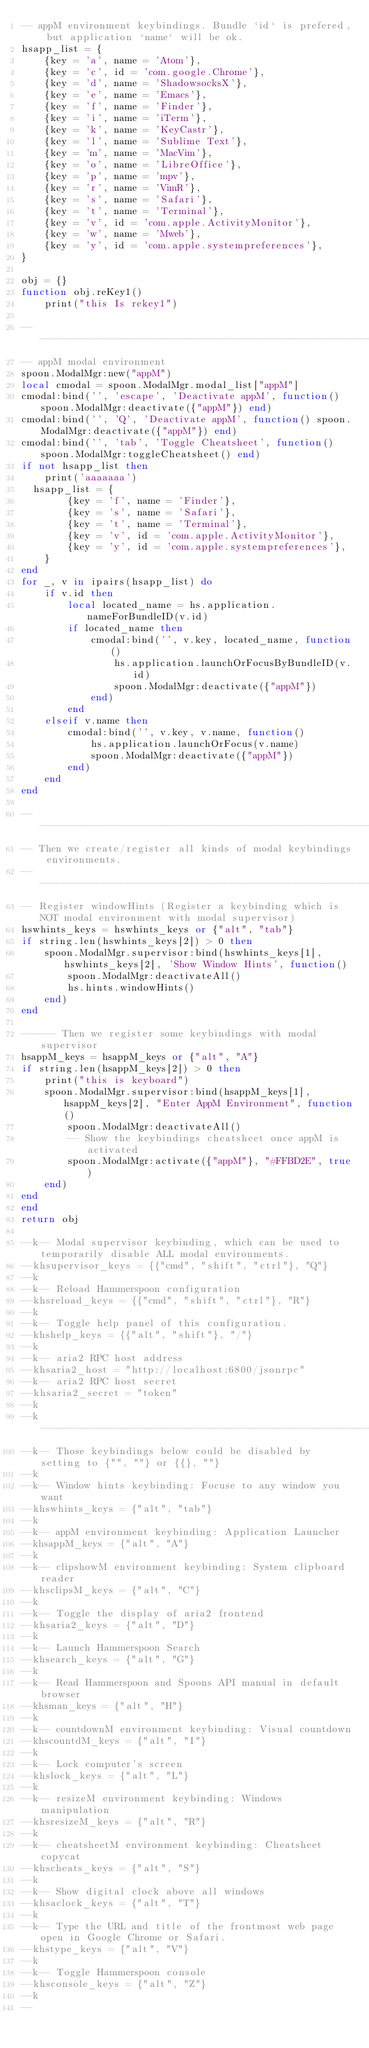<code> <loc_0><loc_0><loc_500><loc_500><_Lua_>-- appM environment keybindings. Bundle `id` is prefered, but application `name` will be ok.
hsapp_list = {
    {key = 'a', name = 'Atom'},
    {key = 'c', id = 'com.google.Chrome'},
    {key = 'd', name = 'ShadowsocksX'},
    {key = 'e', name = 'Emacs'},
    {key = 'f', name = 'Finder'},
    {key = 'i', name = 'iTerm'},
    {key = 'k', name = 'KeyCastr'},
    {key = 'l', name = 'Sublime Text'},
    {key = 'm', name = 'MacVim'},
    {key = 'o', name = 'LibreOffice'},
    {key = 'p', name = 'mpv'},
    {key = 'r', name = 'VimR'},
    {key = 's', name = 'Safari'},
    {key = 't', name = 'Terminal'},
    {key = 'v', id = 'com.apple.ActivityMonitor'},
    {key = 'w', name = 'Mweb'},
    {key = 'y', id = 'com.apple.systempreferences'},
}

obj = {}
function obj.reKey1()
    print("this Is rekey1")
    
----------------------------------------------------------------------------------------------------
-- appM modal environment
spoon.ModalMgr:new("appM")
local cmodal = spoon.ModalMgr.modal_list["appM"]
cmodal:bind('', 'escape', 'Deactivate appM', function() spoon.ModalMgr:deactivate({"appM"}) end)
cmodal:bind('', 'Q', 'Deactivate appM', function() spoon.ModalMgr:deactivate({"appM"}) end)
cmodal:bind('', 'tab', 'Toggle Cheatsheet', function() spoon.ModalMgr:toggleCheatsheet() end)
if not hsapp_list then
    print('aaaaaaa')
  hsapp_list = {
        {key = 'f', name = 'Finder'},
        {key = 's', name = 'Safari'},
        {key = 't', name = 'Terminal'},
        {key = 'v', id = 'com.apple.ActivityMonitor'},
        {key = 'y', id = 'com.apple.systempreferences'},
    }
end
for _, v in ipairs(hsapp_list) do
    if v.id then
        local located_name = hs.application.nameForBundleID(v.id)
        if located_name then
            cmodal:bind('', v.key, located_name, function()
                hs.application.launchOrFocusByBundleID(v.id)
                spoon.ModalMgr:deactivate({"appM"})
            end)
        end
    elseif v.name then
        cmodal:bind('', v.key, v.name, function()
            hs.application.launchOrFocus(v.name)
            spoon.ModalMgr:deactivate({"appM"})
        end)
    end
end

----------------------------------------------------------------------------------------------------
-- Then we create/register all kinds of modal keybindings environments.
----------------------------------------------------------------------------------------------------
-- Register windowHints (Register a keybinding which is NOT modal environment with modal supervisor)
hswhints_keys = hswhints_keys or {"alt", "tab"}
if string.len(hswhints_keys[2]) > 0 then
    spoon.ModalMgr.supervisor:bind(hswhints_keys[1], hswhints_keys[2], 'Show Window Hints', function()
        spoon.ModalMgr:deactivateAll()
        hs.hints.windowHints()
    end)
end

------ Then we register some keybindings with modal supervisor
hsappM_keys = hsappM_keys or {"alt", "A"}
if string.len(hsappM_keys[2]) > 0 then
    print("this is keyboard")
    spoon.ModalMgr.supervisor:bind(hsappM_keys[1], hsappM_keys[2], "Enter AppM Environment", function()
        spoon.ModalMgr:deactivateAll()
        -- Show the keybindings cheatsheet once appM is activated
        spoon.ModalMgr:activate({"appM"}, "#FFBD2E", true)
    end)
end
end
return obj

--k-- Modal supervisor keybinding, which can be used to temporarily disable ALL modal environments.
--khsupervisor_keys = {{"cmd", "shift", "ctrl"}, "Q"}
--k
--k-- Reload Hammerspoon configuration
--khsreload_keys = {{"cmd", "shift", "ctrl"}, "R"}
--k
--k-- Toggle help panel of this configuration.
--khshelp_keys = {{"alt", "shift"}, "/"}
--k
--k-- aria2 RPC host address
--khsaria2_host = "http://localhost:6800/jsonrpc"
--k-- aria2 RPC host secret
--khsaria2_secret = "token"
--k
--k----------------------------------------------------------------------------------------------------
--k-- Those keybindings below could be disabled by setting to {"", ""} or {{}, ""}
--k
--k-- Window hints keybinding: Focuse to any window you want
--khswhints_keys = {"alt", "tab"}
--k
--k-- appM environment keybinding: Application Launcher
--khsappM_keys = {"alt", "A"}
--k
--k-- clipshowM environment keybinding: System clipboard reader
--khsclipsM_keys = {"alt", "C"}
--k
--k-- Toggle the display of aria2 frontend
--khsaria2_keys = {"alt", "D"}
--k
--k-- Launch Hammerspoon Search
--khsearch_keys = {"alt", "G"}
--k
--k-- Read Hammerspoon and Spoons API manual in default browser
--khsman_keys = {"alt", "H"}
--k
--k-- countdownM environment keybinding: Visual countdown
--khscountdM_keys = {"alt", "I"}
--k
--k-- Lock computer's screen
--khslock_keys = {"alt", "L"}
--k
--k-- resizeM environment keybinding: Windows manipulation
--khsresizeM_keys = {"alt", "R"}
--k
--k-- cheatsheetM environment keybinding: Cheatsheet copycat
--khscheats_keys = {"alt", "S"}
--k
--k-- Show digital clock above all windows
--khsaclock_keys = {"alt", "T"}
--k
--k-- Type the URL and title of the frontmost web page open in Google Chrome or Safari.
--khstype_keys = {"alt", "V"}
--k
--k-- Toggle Hammerspoon console
--khsconsole_keys = {"alt", "Z"}
--k
--
</code> 